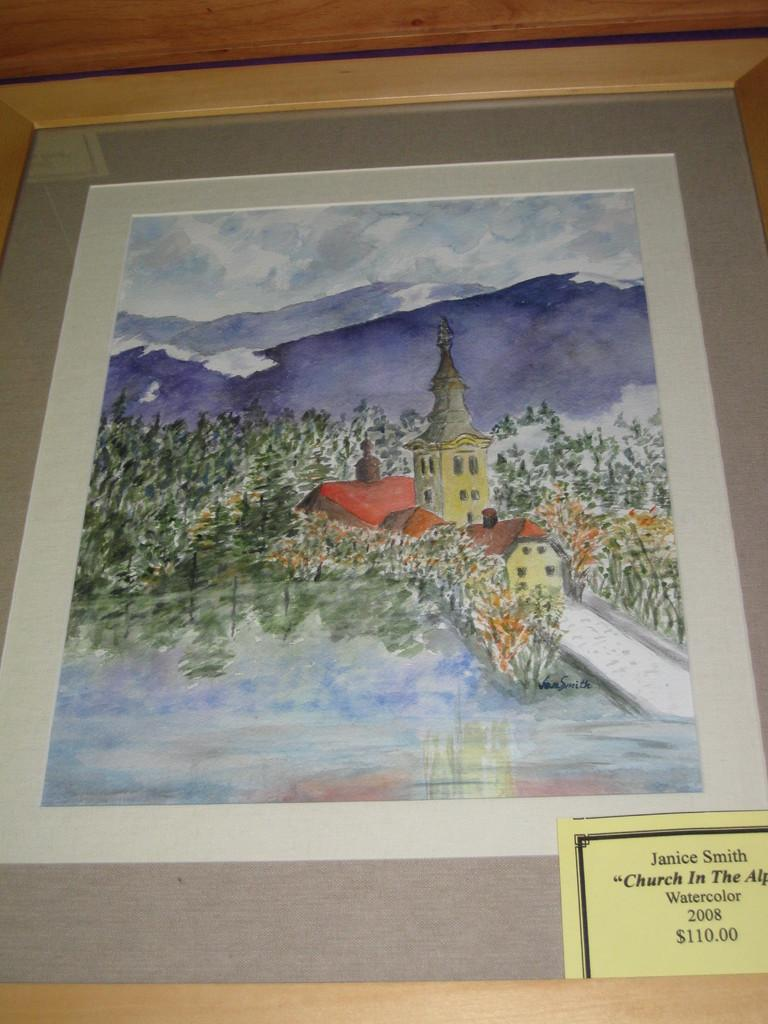<image>
Describe the image concisely. A watercolor painting by Janice Smith is for sale for $110. 